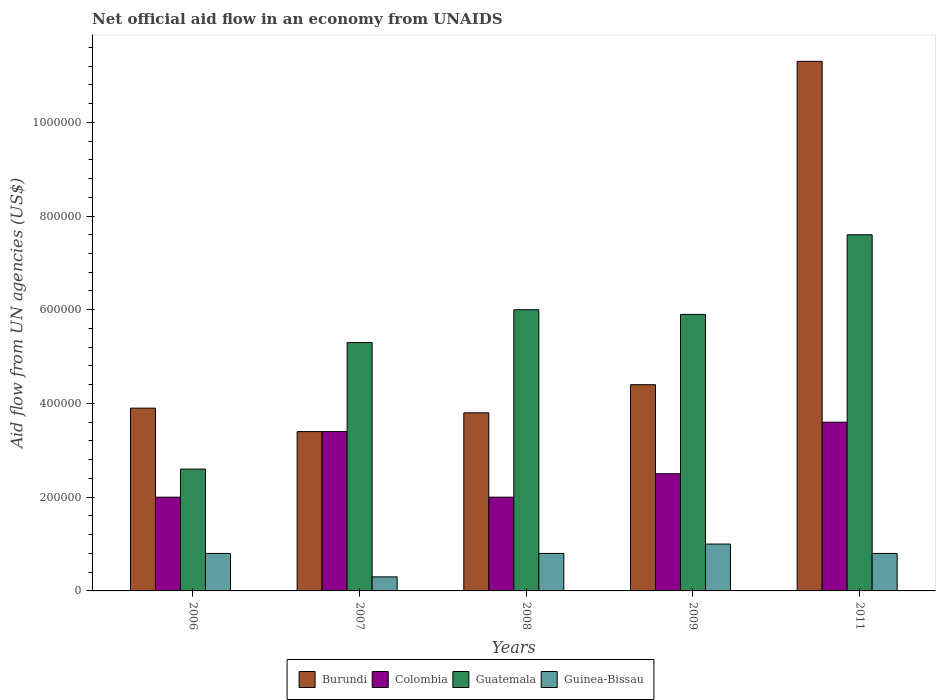How many different coloured bars are there?
Provide a succinct answer. 4. Are the number of bars on each tick of the X-axis equal?
Provide a succinct answer. Yes. How many bars are there on the 2nd tick from the right?
Your answer should be very brief. 4. What is the net official aid flow in Burundi in 2009?
Give a very brief answer. 4.40e+05. Across all years, what is the maximum net official aid flow in Guatemala?
Your answer should be very brief. 7.60e+05. Across all years, what is the minimum net official aid flow in Guinea-Bissau?
Your answer should be very brief. 3.00e+04. In which year was the net official aid flow in Burundi maximum?
Offer a terse response. 2011. What is the total net official aid flow in Colombia in the graph?
Your response must be concise. 1.35e+06. What is the difference between the net official aid flow in Guatemala in 2006 and that in 2011?
Offer a terse response. -5.00e+05. What is the difference between the net official aid flow in Colombia in 2007 and the net official aid flow in Burundi in 2011?
Give a very brief answer. -7.90e+05. What is the average net official aid flow in Guatemala per year?
Make the answer very short. 5.48e+05. In the year 2008, what is the difference between the net official aid flow in Guatemala and net official aid flow in Burundi?
Offer a very short reply. 2.20e+05. In how many years, is the net official aid flow in Guinea-Bissau greater than 320000 US$?
Provide a succinct answer. 0. What is the ratio of the net official aid flow in Colombia in 2006 to that in 2011?
Ensure brevity in your answer.  0.56. Is the net official aid flow in Burundi in 2006 less than that in 2008?
Provide a succinct answer. No. What is the difference between the highest and the second highest net official aid flow in Guinea-Bissau?
Your answer should be compact. 2.00e+04. Is the sum of the net official aid flow in Colombia in 2007 and 2008 greater than the maximum net official aid flow in Burundi across all years?
Your answer should be compact. No. What does the 1st bar from the left in 2007 represents?
Keep it short and to the point. Burundi. What does the 2nd bar from the right in 2009 represents?
Make the answer very short. Guatemala. How many bars are there?
Your answer should be very brief. 20. What is the difference between two consecutive major ticks on the Y-axis?
Your response must be concise. 2.00e+05. Where does the legend appear in the graph?
Provide a succinct answer. Bottom center. How many legend labels are there?
Provide a short and direct response. 4. How are the legend labels stacked?
Make the answer very short. Horizontal. What is the title of the graph?
Your response must be concise. Net official aid flow in an economy from UNAIDS. Does "Chile" appear as one of the legend labels in the graph?
Offer a very short reply. No. What is the label or title of the Y-axis?
Offer a terse response. Aid flow from UN agencies (US$). What is the Aid flow from UN agencies (US$) in Guatemala in 2006?
Offer a very short reply. 2.60e+05. What is the Aid flow from UN agencies (US$) of Colombia in 2007?
Offer a very short reply. 3.40e+05. What is the Aid flow from UN agencies (US$) in Guatemala in 2007?
Offer a terse response. 5.30e+05. What is the Aid flow from UN agencies (US$) in Guinea-Bissau in 2007?
Your answer should be compact. 3.00e+04. What is the Aid flow from UN agencies (US$) in Colombia in 2008?
Offer a terse response. 2.00e+05. What is the Aid flow from UN agencies (US$) of Guinea-Bissau in 2008?
Provide a succinct answer. 8.00e+04. What is the Aid flow from UN agencies (US$) of Burundi in 2009?
Keep it short and to the point. 4.40e+05. What is the Aid flow from UN agencies (US$) in Colombia in 2009?
Your answer should be compact. 2.50e+05. What is the Aid flow from UN agencies (US$) in Guatemala in 2009?
Make the answer very short. 5.90e+05. What is the Aid flow from UN agencies (US$) in Guinea-Bissau in 2009?
Your answer should be very brief. 1.00e+05. What is the Aid flow from UN agencies (US$) of Burundi in 2011?
Provide a short and direct response. 1.13e+06. What is the Aid flow from UN agencies (US$) in Colombia in 2011?
Offer a terse response. 3.60e+05. What is the Aid flow from UN agencies (US$) in Guatemala in 2011?
Your response must be concise. 7.60e+05. Across all years, what is the maximum Aid flow from UN agencies (US$) in Burundi?
Your answer should be very brief. 1.13e+06. Across all years, what is the maximum Aid flow from UN agencies (US$) of Colombia?
Give a very brief answer. 3.60e+05. Across all years, what is the maximum Aid flow from UN agencies (US$) of Guatemala?
Provide a short and direct response. 7.60e+05. Across all years, what is the maximum Aid flow from UN agencies (US$) of Guinea-Bissau?
Provide a succinct answer. 1.00e+05. Across all years, what is the minimum Aid flow from UN agencies (US$) of Guatemala?
Provide a succinct answer. 2.60e+05. Across all years, what is the minimum Aid flow from UN agencies (US$) in Guinea-Bissau?
Your answer should be very brief. 3.00e+04. What is the total Aid flow from UN agencies (US$) of Burundi in the graph?
Make the answer very short. 2.68e+06. What is the total Aid flow from UN agencies (US$) in Colombia in the graph?
Your answer should be very brief. 1.35e+06. What is the total Aid flow from UN agencies (US$) in Guatemala in the graph?
Provide a short and direct response. 2.74e+06. What is the difference between the Aid flow from UN agencies (US$) in Guatemala in 2006 and that in 2007?
Give a very brief answer. -2.70e+05. What is the difference between the Aid flow from UN agencies (US$) in Colombia in 2006 and that in 2008?
Your answer should be compact. 0. What is the difference between the Aid flow from UN agencies (US$) in Guinea-Bissau in 2006 and that in 2008?
Give a very brief answer. 0. What is the difference between the Aid flow from UN agencies (US$) of Burundi in 2006 and that in 2009?
Ensure brevity in your answer.  -5.00e+04. What is the difference between the Aid flow from UN agencies (US$) of Colombia in 2006 and that in 2009?
Give a very brief answer. -5.00e+04. What is the difference between the Aid flow from UN agencies (US$) in Guatemala in 2006 and that in 2009?
Make the answer very short. -3.30e+05. What is the difference between the Aid flow from UN agencies (US$) of Burundi in 2006 and that in 2011?
Keep it short and to the point. -7.40e+05. What is the difference between the Aid flow from UN agencies (US$) in Guatemala in 2006 and that in 2011?
Your answer should be very brief. -5.00e+05. What is the difference between the Aid flow from UN agencies (US$) in Guinea-Bissau in 2006 and that in 2011?
Your answer should be very brief. 0. What is the difference between the Aid flow from UN agencies (US$) of Guatemala in 2007 and that in 2008?
Provide a short and direct response. -7.00e+04. What is the difference between the Aid flow from UN agencies (US$) of Burundi in 2007 and that in 2009?
Your response must be concise. -1.00e+05. What is the difference between the Aid flow from UN agencies (US$) in Colombia in 2007 and that in 2009?
Keep it short and to the point. 9.00e+04. What is the difference between the Aid flow from UN agencies (US$) of Guinea-Bissau in 2007 and that in 2009?
Your answer should be compact. -7.00e+04. What is the difference between the Aid flow from UN agencies (US$) of Burundi in 2007 and that in 2011?
Your answer should be compact. -7.90e+05. What is the difference between the Aid flow from UN agencies (US$) of Colombia in 2007 and that in 2011?
Provide a short and direct response. -2.00e+04. What is the difference between the Aid flow from UN agencies (US$) in Guinea-Bissau in 2007 and that in 2011?
Offer a very short reply. -5.00e+04. What is the difference between the Aid flow from UN agencies (US$) of Burundi in 2008 and that in 2009?
Your answer should be very brief. -6.00e+04. What is the difference between the Aid flow from UN agencies (US$) of Colombia in 2008 and that in 2009?
Your answer should be very brief. -5.00e+04. What is the difference between the Aid flow from UN agencies (US$) of Guatemala in 2008 and that in 2009?
Offer a terse response. 10000. What is the difference between the Aid flow from UN agencies (US$) of Guinea-Bissau in 2008 and that in 2009?
Offer a terse response. -2.00e+04. What is the difference between the Aid flow from UN agencies (US$) of Burundi in 2008 and that in 2011?
Give a very brief answer. -7.50e+05. What is the difference between the Aid flow from UN agencies (US$) of Colombia in 2008 and that in 2011?
Offer a terse response. -1.60e+05. What is the difference between the Aid flow from UN agencies (US$) in Burundi in 2009 and that in 2011?
Keep it short and to the point. -6.90e+05. What is the difference between the Aid flow from UN agencies (US$) in Colombia in 2009 and that in 2011?
Provide a succinct answer. -1.10e+05. What is the difference between the Aid flow from UN agencies (US$) of Guinea-Bissau in 2009 and that in 2011?
Your response must be concise. 2.00e+04. What is the difference between the Aid flow from UN agencies (US$) of Burundi in 2006 and the Aid flow from UN agencies (US$) of Colombia in 2007?
Make the answer very short. 5.00e+04. What is the difference between the Aid flow from UN agencies (US$) of Burundi in 2006 and the Aid flow from UN agencies (US$) of Guatemala in 2007?
Keep it short and to the point. -1.40e+05. What is the difference between the Aid flow from UN agencies (US$) in Colombia in 2006 and the Aid flow from UN agencies (US$) in Guatemala in 2007?
Provide a short and direct response. -3.30e+05. What is the difference between the Aid flow from UN agencies (US$) of Colombia in 2006 and the Aid flow from UN agencies (US$) of Guinea-Bissau in 2007?
Your answer should be very brief. 1.70e+05. What is the difference between the Aid flow from UN agencies (US$) of Guatemala in 2006 and the Aid flow from UN agencies (US$) of Guinea-Bissau in 2007?
Provide a short and direct response. 2.30e+05. What is the difference between the Aid flow from UN agencies (US$) in Burundi in 2006 and the Aid flow from UN agencies (US$) in Colombia in 2008?
Make the answer very short. 1.90e+05. What is the difference between the Aid flow from UN agencies (US$) in Burundi in 2006 and the Aid flow from UN agencies (US$) in Guatemala in 2008?
Provide a succinct answer. -2.10e+05. What is the difference between the Aid flow from UN agencies (US$) in Colombia in 2006 and the Aid flow from UN agencies (US$) in Guatemala in 2008?
Make the answer very short. -4.00e+05. What is the difference between the Aid flow from UN agencies (US$) of Colombia in 2006 and the Aid flow from UN agencies (US$) of Guinea-Bissau in 2008?
Your answer should be compact. 1.20e+05. What is the difference between the Aid flow from UN agencies (US$) in Guatemala in 2006 and the Aid flow from UN agencies (US$) in Guinea-Bissau in 2008?
Your response must be concise. 1.80e+05. What is the difference between the Aid flow from UN agencies (US$) of Colombia in 2006 and the Aid flow from UN agencies (US$) of Guatemala in 2009?
Ensure brevity in your answer.  -3.90e+05. What is the difference between the Aid flow from UN agencies (US$) in Burundi in 2006 and the Aid flow from UN agencies (US$) in Guatemala in 2011?
Provide a short and direct response. -3.70e+05. What is the difference between the Aid flow from UN agencies (US$) in Colombia in 2006 and the Aid flow from UN agencies (US$) in Guatemala in 2011?
Provide a succinct answer. -5.60e+05. What is the difference between the Aid flow from UN agencies (US$) of Burundi in 2007 and the Aid flow from UN agencies (US$) of Guatemala in 2008?
Your answer should be very brief. -2.60e+05. What is the difference between the Aid flow from UN agencies (US$) in Burundi in 2007 and the Aid flow from UN agencies (US$) in Colombia in 2009?
Make the answer very short. 9.00e+04. What is the difference between the Aid flow from UN agencies (US$) in Burundi in 2007 and the Aid flow from UN agencies (US$) in Guatemala in 2009?
Your answer should be compact. -2.50e+05. What is the difference between the Aid flow from UN agencies (US$) of Colombia in 2007 and the Aid flow from UN agencies (US$) of Guatemala in 2009?
Your answer should be very brief. -2.50e+05. What is the difference between the Aid flow from UN agencies (US$) of Burundi in 2007 and the Aid flow from UN agencies (US$) of Colombia in 2011?
Make the answer very short. -2.00e+04. What is the difference between the Aid flow from UN agencies (US$) of Burundi in 2007 and the Aid flow from UN agencies (US$) of Guatemala in 2011?
Offer a terse response. -4.20e+05. What is the difference between the Aid flow from UN agencies (US$) of Burundi in 2007 and the Aid flow from UN agencies (US$) of Guinea-Bissau in 2011?
Your response must be concise. 2.60e+05. What is the difference between the Aid flow from UN agencies (US$) in Colombia in 2007 and the Aid flow from UN agencies (US$) in Guatemala in 2011?
Offer a very short reply. -4.20e+05. What is the difference between the Aid flow from UN agencies (US$) of Guatemala in 2007 and the Aid flow from UN agencies (US$) of Guinea-Bissau in 2011?
Give a very brief answer. 4.50e+05. What is the difference between the Aid flow from UN agencies (US$) in Burundi in 2008 and the Aid flow from UN agencies (US$) in Colombia in 2009?
Offer a very short reply. 1.30e+05. What is the difference between the Aid flow from UN agencies (US$) in Colombia in 2008 and the Aid flow from UN agencies (US$) in Guatemala in 2009?
Your answer should be compact. -3.90e+05. What is the difference between the Aid flow from UN agencies (US$) of Burundi in 2008 and the Aid flow from UN agencies (US$) of Colombia in 2011?
Provide a succinct answer. 2.00e+04. What is the difference between the Aid flow from UN agencies (US$) of Burundi in 2008 and the Aid flow from UN agencies (US$) of Guatemala in 2011?
Your response must be concise. -3.80e+05. What is the difference between the Aid flow from UN agencies (US$) of Burundi in 2008 and the Aid flow from UN agencies (US$) of Guinea-Bissau in 2011?
Offer a very short reply. 3.00e+05. What is the difference between the Aid flow from UN agencies (US$) in Colombia in 2008 and the Aid flow from UN agencies (US$) in Guatemala in 2011?
Your answer should be very brief. -5.60e+05. What is the difference between the Aid flow from UN agencies (US$) in Guatemala in 2008 and the Aid flow from UN agencies (US$) in Guinea-Bissau in 2011?
Give a very brief answer. 5.20e+05. What is the difference between the Aid flow from UN agencies (US$) of Burundi in 2009 and the Aid flow from UN agencies (US$) of Guatemala in 2011?
Make the answer very short. -3.20e+05. What is the difference between the Aid flow from UN agencies (US$) of Burundi in 2009 and the Aid flow from UN agencies (US$) of Guinea-Bissau in 2011?
Provide a succinct answer. 3.60e+05. What is the difference between the Aid flow from UN agencies (US$) in Colombia in 2009 and the Aid flow from UN agencies (US$) in Guatemala in 2011?
Offer a very short reply. -5.10e+05. What is the difference between the Aid flow from UN agencies (US$) in Guatemala in 2009 and the Aid flow from UN agencies (US$) in Guinea-Bissau in 2011?
Keep it short and to the point. 5.10e+05. What is the average Aid flow from UN agencies (US$) of Burundi per year?
Offer a very short reply. 5.36e+05. What is the average Aid flow from UN agencies (US$) of Guatemala per year?
Offer a terse response. 5.48e+05. What is the average Aid flow from UN agencies (US$) in Guinea-Bissau per year?
Your answer should be very brief. 7.40e+04. In the year 2006, what is the difference between the Aid flow from UN agencies (US$) in Burundi and Aid flow from UN agencies (US$) in Colombia?
Offer a very short reply. 1.90e+05. In the year 2006, what is the difference between the Aid flow from UN agencies (US$) in Burundi and Aid flow from UN agencies (US$) in Guinea-Bissau?
Keep it short and to the point. 3.10e+05. In the year 2006, what is the difference between the Aid flow from UN agencies (US$) of Colombia and Aid flow from UN agencies (US$) of Guatemala?
Give a very brief answer. -6.00e+04. In the year 2006, what is the difference between the Aid flow from UN agencies (US$) in Colombia and Aid flow from UN agencies (US$) in Guinea-Bissau?
Provide a succinct answer. 1.20e+05. In the year 2006, what is the difference between the Aid flow from UN agencies (US$) in Guatemala and Aid flow from UN agencies (US$) in Guinea-Bissau?
Ensure brevity in your answer.  1.80e+05. In the year 2007, what is the difference between the Aid flow from UN agencies (US$) of Burundi and Aid flow from UN agencies (US$) of Guinea-Bissau?
Provide a short and direct response. 3.10e+05. In the year 2007, what is the difference between the Aid flow from UN agencies (US$) of Colombia and Aid flow from UN agencies (US$) of Guatemala?
Offer a very short reply. -1.90e+05. In the year 2007, what is the difference between the Aid flow from UN agencies (US$) of Colombia and Aid flow from UN agencies (US$) of Guinea-Bissau?
Your response must be concise. 3.10e+05. In the year 2007, what is the difference between the Aid flow from UN agencies (US$) of Guatemala and Aid flow from UN agencies (US$) of Guinea-Bissau?
Offer a very short reply. 5.00e+05. In the year 2008, what is the difference between the Aid flow from UN agencies (US$) of Burundi and Aid flow from UN agencies (US$) of Colombia?
Provide a short and direct response. 1.80e+05. In the year 2008, what is the difference between the Aid flow from UN agencies (US$) of Burundi and Aid flow from UN agencies (US$) of Guatemala?
Offer a terse response. -2.20e+05. In the year 2008, what is the difference between the Aid flow from UN agencies (US$) in Colombia and Aid flow from UN agencies (US$) in Guatemala?
Provide a succinct answer. -4.00e+05. In the year 2008, what is the difference between the Aid flow from UN agencies (US$) in Guatemala and Aid flow from UN agencies (US$) in Guinea-Bissau?
Provide a short and direct response. 5.20e+05. In the year 2009, what is the difference between the Aid flow from UN agencies (US$) of Burundi and Aid flow from UN agencies (US$) of Guinea-Bissau?
Provide a succinct answer. 3.40e+05. In the year 2009, what is the difference between the Aid flow from UN agencies (US$) of Colombia and Aid flow from UN agencies (US$) of Guatemala?
Provide a succinct answer. -3.40e+05. In the year 2009, what is the difference between the Aid flow from UN agencies (US$) in Colombia and Aid flow from UN agencies (US$) in Guinea-Bissau?
Provide a succinct answer. 1.50e+05. In the year 2011, what is the difference between the Aid flow from UN agencies (US$) in Burundi and Aid flow from UN agencies (US$) in Colombia?
Offer a terse response. 7.70e+05. In the year 2011, what is the difference between the Aid flow from UN agencies (US$) in Burundi and Aid flow from UN agencies (US$) in Guatemala?
Provide a succinct answer. 3.70e+05. In the year 2011, what is the difference between the Aid flow from UN agencies (US$) in Burundi and Aid flow from UN agencies (US$) in Guinea-Bissau?
Your answer should be compact. 1.05e+06. In the year 2011, what is the difference between the Aid flow from UN agencies (US$) in Colombia and Aid flow from UN agencies (US$) in Guatemala?
Your response must be concise. -4.00e+05. In the year 2011, what is the difference between the Aid flow from UN agencies (US$) of Colombia and Aid flow from UN agencies (US$) of Guinea-Bissau?
Ensure brevity in your answer.  2.80e+05. In the year 2011, what is the difference between the Aid flow from UN agencies (US$) of Guatemala and Aid flow from UN agencies (US$) of Guinea-Bissau?
Keep it short and to the point. 6.80e+05. What is the ratio of the Aid flow from UN agencies (US$) of Burundi in 2006 to that in 2007?
Ensure brevity in your answer.  1.15. What is the ratio of the Aid flow from UN agencies (US$) in Colombia in 2006 to that in 2007?
Offer a very short reply. 0.59. What is the ratio of the Aid flow from UN agencies (US$) of Guatemala in 2006 to that in 2007?
Provide a short and direct response. 0.49. What is the ratio of the Aid flow from UN agencies (US$) of Guinea-Bissau in 2006 to that in 2007?
Offer a very short reply. 2.67. What is the ratio of the Aid flow from UN agencies (US$) in Burundi in 2006 to that in 2008?
Your response must be concise. 1.03. What is the ratio of the Aid flow from UN agencies (US$) of Colombia in 2006 to that in 2008?
Your response must be concise. 1. What is the ratio of the Aid flow from UN agencies (US$) of Guatemala in 2006 to that in 2008?
Offer a very short reply. 0.43. What is the ratio of the Aid flow from UN agencies (US$) of Burundi in 2006 to that in 2009?
Offer a terse response. 0.89. What is the ratio of the Aid flow from UN agencies (US$) of Guatemala in 2006 to that in 2009?
Provide a short and direct response. 0.44. What is the ratio of the Aid flow from UN agencies (US$) in Burundi in 2006 to that in 2011?
Provide a short and direct response. 0.35. What is the ratio of the Aid flow from UN agencies (US$) in Colombia in 2006 to that in 2011?
Keep it short and to the point. 0.56. What is the ratio of the Aid flow from UN agencies (US$) in Guatemala in 2006 to that in 2011?
Provide a succinct answer. 0.34. What is the ratio of the Aid flow from UN agencies (US$) of Burundi in 2007 to that in 2008?
Offer a very short reply. 0.89. What is the ratio of the Aid flow from UN agencies (US$) of Guatemala in 2007 to that in 2008?
Your answer should be compact. 0.88. What is the ratio of the Aid flow from UN agencies (US$) of Guinea-Bissau in 2007 to that in 2008?
Provide a succinct answer. 0.38. What is the ratio of the Aid flow from UN agencies (US$) in Burundi in 2007 to that in 2009?
Ensure brevity in your answer.  0.77. What is the ratio of the Aid flow from UN agencies (US$) of Colombia in 2007 to that in 2009?
Give a very brief answer. 1.36. What is the ratio of the Aid flow from UN agencies (US$) in Guatemala in 2007 to that in 2009?
Offer a terse response. 0.9. What is the ratio of the Aid flow from UN agencies (US$) of Guinea-Bissau in 2007 to that in 2009?
Provide a short and direct response. 0.3. What is the ratio of the Aid flow from UN agencies (US$) of Burundi in 2007 to that in 2011?
Provide a succinct answer. 0.3. What is the ratio of the Aid flow from UN agencies (US$) in Colombia in 2007 to that in 2011?
Your answer should be very brief. 0.94. What is the ratio of the Aid flow from UN agencies (US$) in Guatemala in 2007 to that in 2011?
Provide a succinct answer. 0.7. What is the ratio of the Aid flow from UN agencies (US$) of Burundi in 2008 to that in 2009?
Make the answer very short. 0.86. What is the ratio of the Aid flow from UN agencies (US$) of Guatemala in 2008 to that in 2009?
Provide a succinct answer. 1.02. What is the ratio of the Aid flow from UN agencies (US$) in Guinea-Bissau in 2008 to that in 2009?
Provide a succinct answer. 0.8. What is the ratio of the Aid flow from UN agencies (US$) in Burundi in 2008 to that in 2011?
Give a very brief answer. 0.34. What is the ratio of the Aid flow from UN agencies (US$) of Colombia in 2008 to that in 2011?
Your answer should be very brief. 0.56. What is the ratio of the Aid flow from UN agencies (US$) of Guatemala in 2008 to that in 2011?
Ensure brevity in your answer.  0.79. What is the ratio of the Aid flow from UN agencies (US$) of Guinea-Bissau in 2008 to that in 2011?
Provide a short and direct response. 1. What is the ratio of the Aid flow from UN agencies (US$) in Burundi in 2009 to that in 2011?
Provide a short and direct response. 0.39. What is the ratio of the Aid flow from UN agencies (US$) in Colombia in 2009 to that in 2011?
Your answer should be very brief. 0.69. What is the ratio of the Aid flow from UN agencies (US$) in Guatemala in 2009 to that in 2011?
Give a very brief answer. 0.78. What is the ratio of the Aid flow from UN agencies (US$) of Guinea-Bissau in 2009 to that in 2011?
Your response must be concise. 1.25. What is the difference between the highest and the second highest Aid flow from UN agencies (US$) of Burundi?
Provide a succinct answer. 6.90e+05. What is the difference between the highest and the second highest Aid flow from UN agencies (US$) of Colombia?
Offer a terse response. 2.00e+04. What is the difference between the highest and the second highest Aid flow from UN agencies (US$) in Guatemala?
Your response must be concise. 1.60e+05. What is the difference between the highest and the lowest Aid flow from UN agencies (US$) of Burundi?
Offer a very short reply. 7.90e+05. What is the difference between the highest and the lowest Aid flow from UN agencies (US$) of Guinea-Bissau?
Provide a succinct answer. 7.00e+04. 